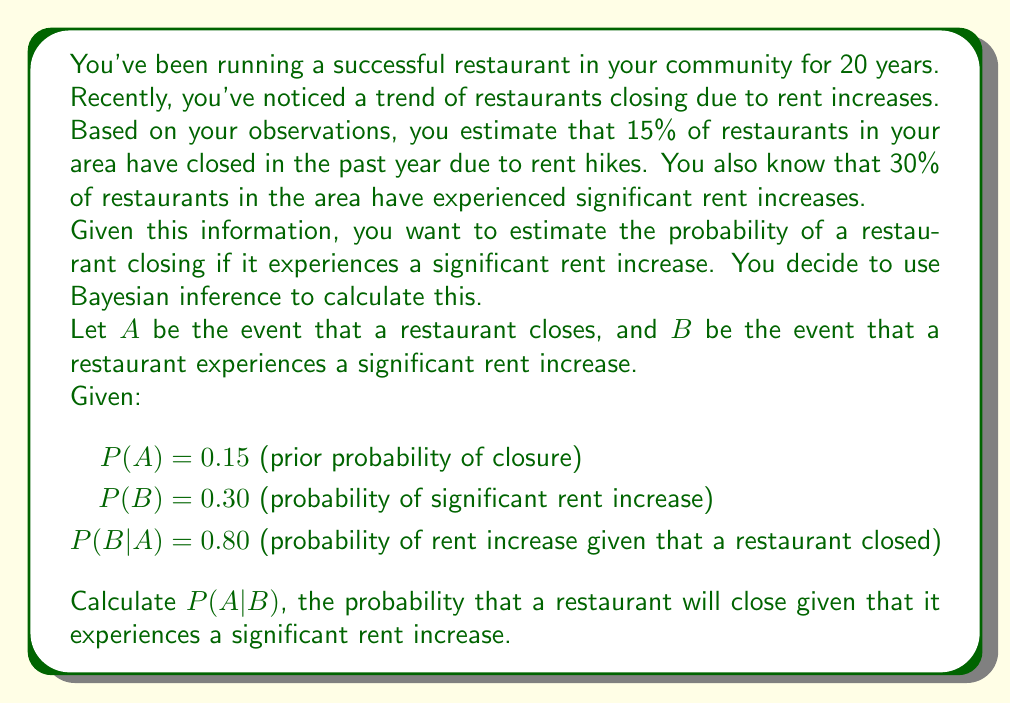Teach me how to tackle this problem. To solve this problem, we'll use Bayes' theorem, which is given by:

$$P(A|B) = \frac{P(B|A) \cdot P(A)}{P(B)}$$

We're given:
- P(A) = 0.15 (prior probability of closure)
- P(B) = 0.30 (probability of significant rent increase)
- P(B|A) = 0.80 (probability of rent increase given that a restaurant closed)

Let's follow these steps:

1) First, we need to calculate P(B) using the law of total probability:

   $$P(B) = P(B|A) \cdot P(A) + P(B|\text{not }A) \cdot P(\text{not }A)$$

   We know P(B|A), P(A), and P(B), but we need to calculate P(B|not A):

   $$0.30 = 0.80 \cdot 0.15 + P(B|\text{not }A) \cdot 0.85$$
   $$0.30 = 0.12 + 0.85 \cdot P(B|\text{not }A)$$
   $$0.18 = 0.85 \cdot P(B|\text{not }A)$$
   $$P(B|\text{not }A) = 0.2118$$

2) Now we can apply Bayes' theorem:

   $$P(A|B) = \frac{P(B|A) \cdot P(A)}{P(B)}$$

3) Substitute the known values:

   $$P(A|B) = \frac{0.80 \cdot 0.15}{0.30}$$

4) Calculate:

   $$P(A|B) = \frac{0.12}{0.30} = 0.40$$

Therefore, the probability that a restaurant will close given that it experiences a significant rent increase is 0.40 or 40%.
Answer: P(A|B) = 0.40 or 40% 